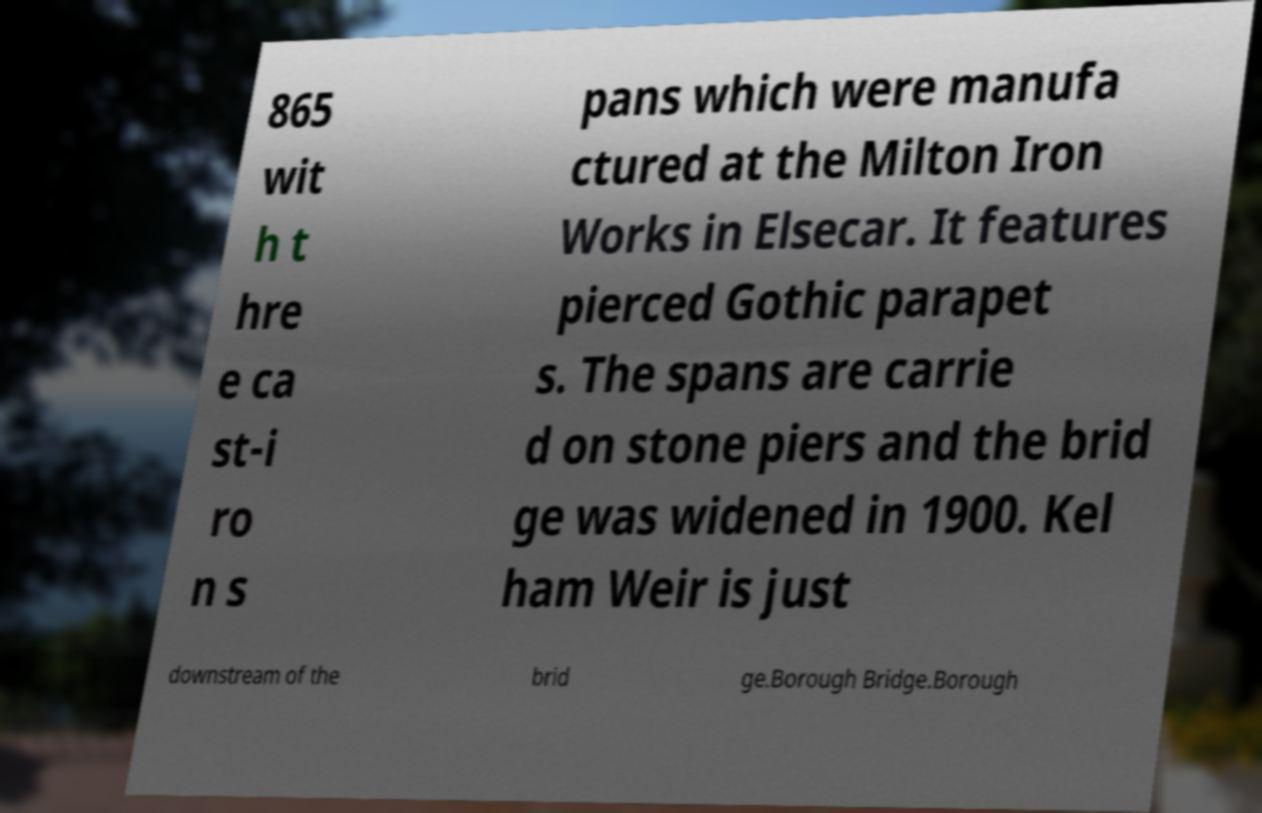There's text embedded in this image that I need extracted. Can you transcribe it verbatim? 865 wit h t hre e ca st-i ro n s pans which were manufa ctured at the Milton Iron Works in Elsecar. It features pierced Gothic parapet s. The spans are carrie d on stone piers and the brid ge was widened in 1900. Kel ham Weir is just downstream of the brid ge.Borough Bridge.Borough 